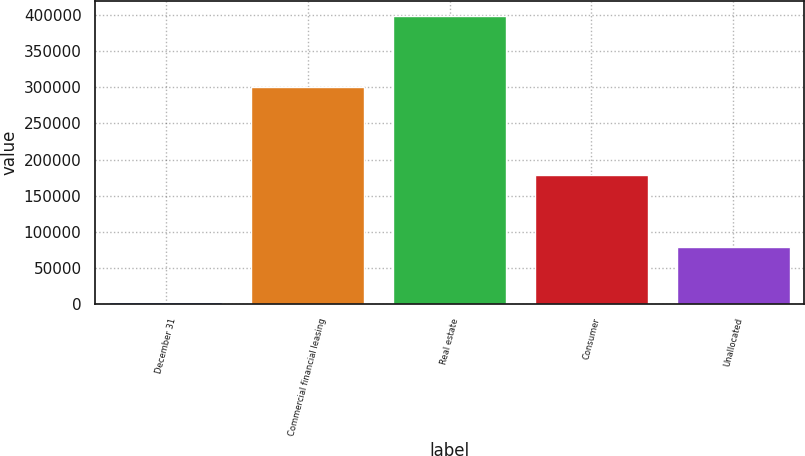Convert chart. <chart><loc_0><loc_0><loc_500><loc_500><bar_chart><fcel>December 31<fcel>Commercial financial leasing<fcel>Real estate<fcel>Consumer<fcel>Unallocated<nl><fcel>2015<fcel>300404<fcel>399069<fcel>178320<fcel>78199<nl></chart> 